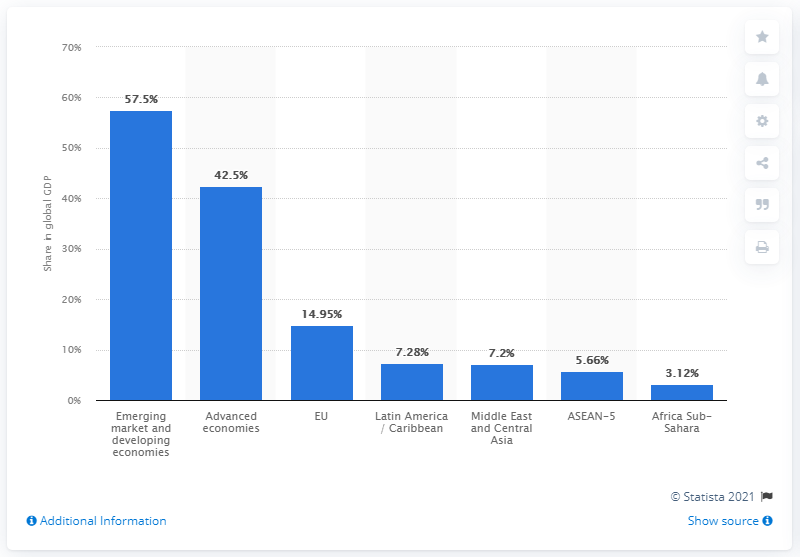Draw attention to some important aspects in this diagram. In 2020, the share of industrialized countries in the global gross domestic product (GDP) was 42.5%. 